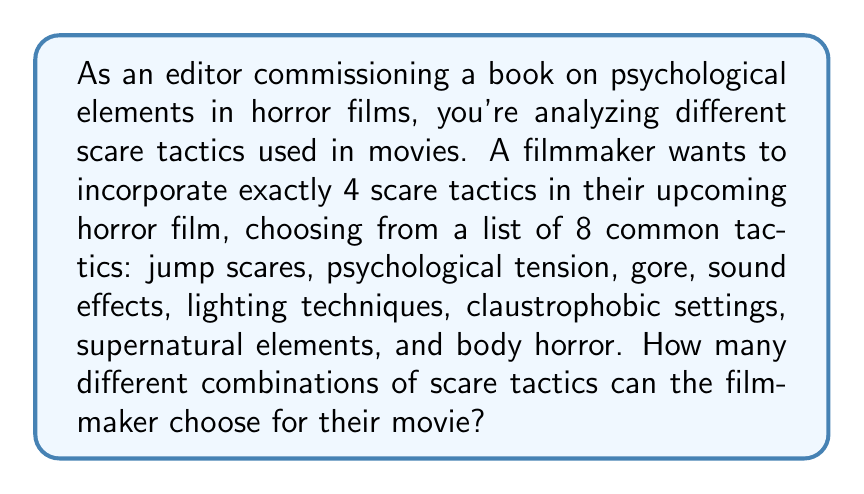Can you answer this question? To solve this problem, we need to use the combination formula. We are selecting 4 items from a set of 8, where the order doesn't matter (as we're just interested in which tactics are used, not the order they appear in the film).

The formula for combinations is:

$$ C(n,r) = \frac{n!}{r!(n-r)!} $$

Where:
$n$ is the total number of items to choose from (in this case, 8 scare tactics)
$r$ is the number of items being chosen (in this case, 4 tactics)

Plugging in our values:

$$ C(8,4) = \frac{8!}{4!(8-4)!} = \frac{8!}{4!4!} $$

Now, let's calculate this step by step:

1) First, expand this:
   $$ \frac{8 * 7 * 6 * 5 * 4!}{4! * 4 * 3 * 2 * 1} $$

2) The 4! cancels out in the numerator and denominator:
   $$ \frac{8 * 7 * 6 * 5}{4 * 3 * 2 * 1} $$

3) Multiply the numerator and denominator:
   $$ \frac{1680}{24} $$

4) Divide:
   $$ 70 $$

Therefore, there are 70 different combinations of 4 scare tactics that can be chosen from a list of 8.
Answer: 70 combinations 